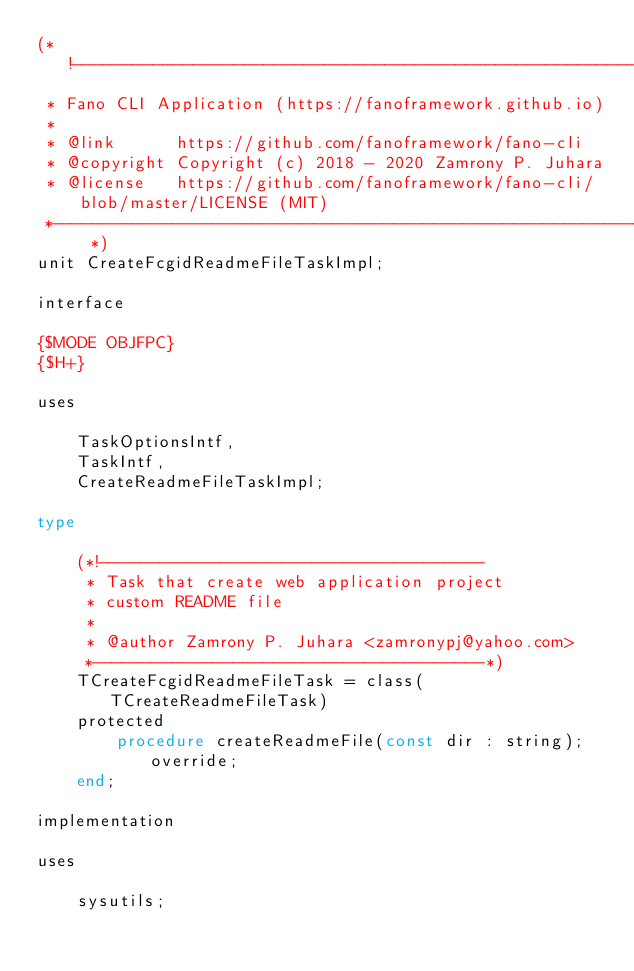Convert code to text. <code><loc_0><loc_0><loc_500><loc_500><_Pascal_>(*!------------------------------------------------------------
 * Fano CLI Application (https://fanoframework.github.io)
 *
 * @link      https://github.com/fanoframework/fano-cli
 * @copyright Copyright (c) 2018 - 2020 Zamrony P. Juhara
 * @license   https://github.com/fanoframework/fano-cli/blob/master/LICENSE (MIT)
 *------------------------------------------------------------- *)
unit CreateFcgidReadmeFileTaskImpl;

interface

{$MODE OBJFPC}
{$H+}

uses

    TaskOptionsIntf,
    TaskIntf,
    CreateReadmeFileTaskImpl;

type

    (*!--------------------------------------
     * Task that create web application project
     * custom README file
     *
     * @author Zamrony P. Juhara <zamronypj@yahoo.com>
     *---------------------------------------*)
    TCreateFcgidReadmeFileTask = class(TCreateReadmeFileTask)
    protected
        procedure createReadmeFile(const dir : string); override;
    end;

implementation

uses

    sysutils;
</code> 